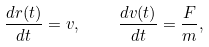<formula> <loc_0><loc_0><loc_500><loc_500>\frac { d { r } ( t ) } { d t } = { v } , \quad \frac { d { v } ( t ) } { d t } = \frac { F } m ,</formula> 